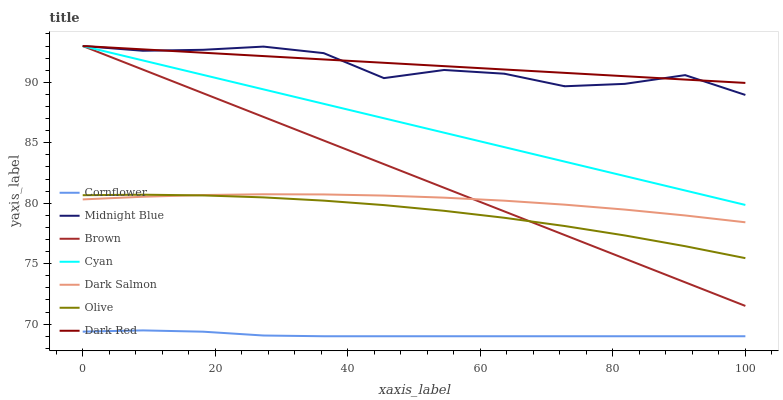Does Cornflower have the minimum area under the curve?
Answer yes or no. Yes. Does Dark Red have the maximum area under the curve?
Answer yes or no. Yes. Does Midnight Blue have the minimum area under the curve?
Answer yes or no. No. Does Midnight Blue have the maximum area under the curve?
Answer yes or no. No. Is Cyan the smoothest?
Answer yes or no. Yes. Is Midnight Blue the roughest?
Answer yes or no. Yes. Is Brown the smoothest?
Answer yes or no. No. Is Brown the roughest?
Answer yes or no. No. Does Cornflower have the lowest value?
Answer yes or no. Yes. Does Midnight Blue have the lowest value?
Answer yes or no. No. Does Cyan have the highest value?
Answer yes or no. Yes. Does Dark Salmon have the highest value?
Answer yes or no. No. Is Olive less than Dark Red?
Answer yes or no. Yes. Is Midnight Blue greater than Olive?
Answer yes or no. Yes. Does Brown intersect Midnight Blue?
Answer yes or no. Yes. Is Brown less than Midnight Blue?
Answer yes or no. No. Is Brown greater than Midnight Blue?
Answer yes or no. No. Does Olive intersect Dark Red?
Answer yes or no. No. 